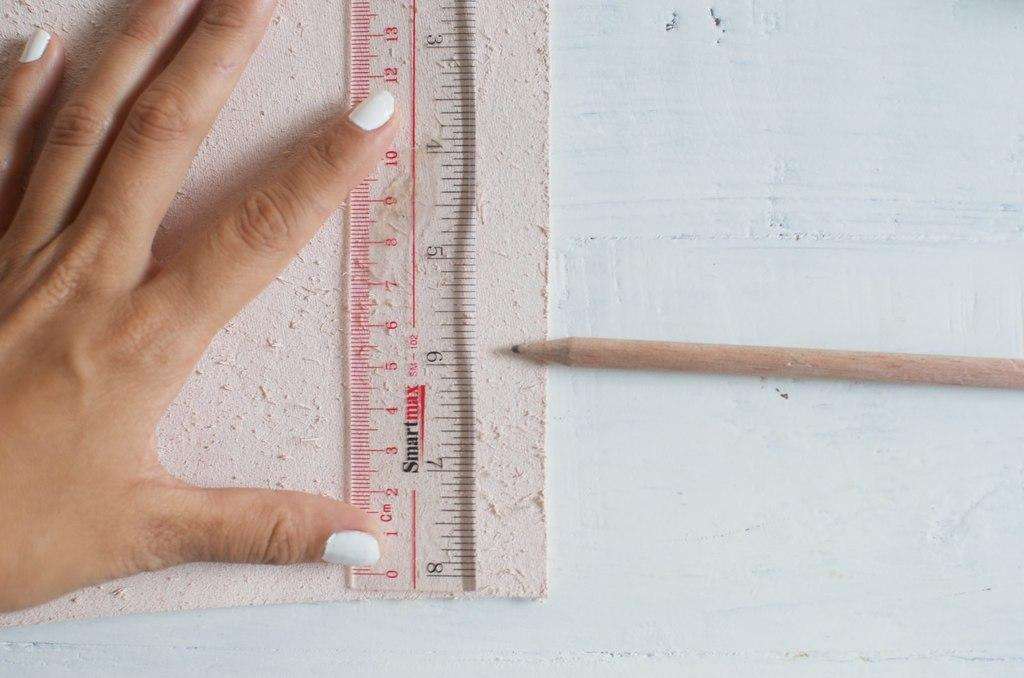<image>
Write a terse but informative summary of the picture. A ruler, made by Smart max, displays many different numbers. 